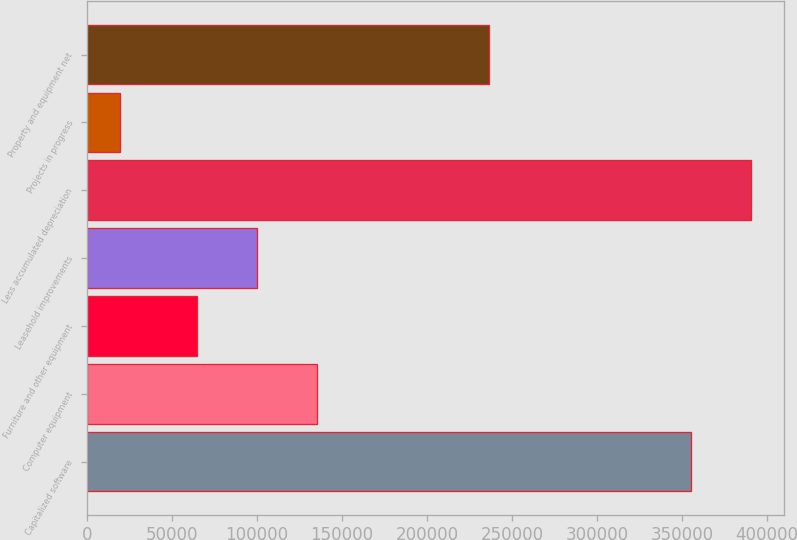Convert chart to OTSL. <chart><loc_0><loc_0><loc_500><loc_500><bar_chart><fcel>Capitalized software<fcel>Computer equipment<fcel>Furniture and other equipment<fcel>Leasehold improvements<fcel>Less accumulated depreciation<fcel>Projects in progress<fcel>Property and equipment net<nl><fcel>355088<fcel>135628<fcel>65098<fcel>100363<fcel>390353<fcel>19401<fcel>236820<nl></chart> 